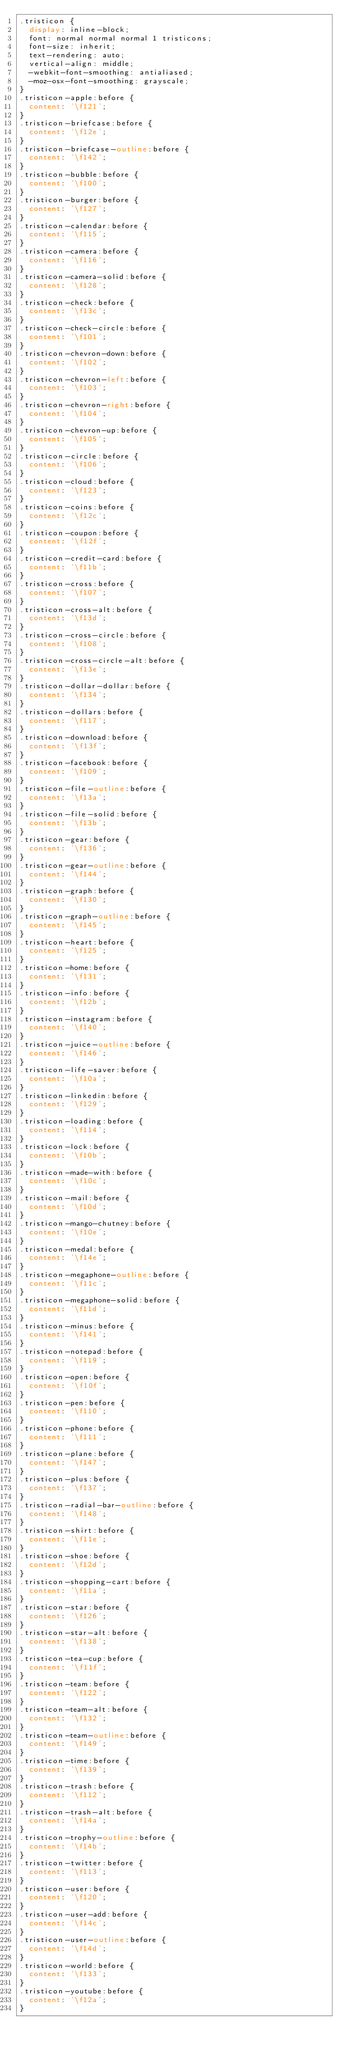Convert code to text. <code><loc_0><loc_0><loc_500><loc_500><_CSS_>.tristicon {
  display: inline-block;
  font: normal normal normal 1 tristicons;
  font-size: inherit;
  text-rendering: auto;
  vertical-align: middle;
  -webkit-font-smoothing: antialiased;
  -moz-osx-font-smoothing: grayscale;
}
.tristicon-apple:before {
  content: '\f121';
}
.tristicon-briefcase:before {
  content: '\f12e';
}
.tristicon-briefcase-outline:before {
  content: '\f142';
}
.tristicon-bubble:before {
  content: '\f100';
}
.tristicon-burger:before {
  content: '\f127';
}
.tristicon-calendar:before {
  content: '\f115';
}
.tristicon-camera:before {
  content: '\f116';
}
.tristicon-camera-solid:before {
  content: '\f128';
}
.tristicon-check:before {
  content: '\f13c';
}
.tristicon-check-circle:before {
  content: '\f101';
}
.tristicon-chevron-down:before {
  content: '\f102';
}
.tristicon-chevron-left:before {
  content: '\f103';
}
.tristicon-chevron-right:before {
  content: '\f104';
}
.tristicon-chevron-up:before {
  content: '\f105';
}
.tristicon-circle:before {
  content: '\f106';
}
.tristicon-cloud:before {
  content: '\f123';
}
.tristicon-coins:before {
  content: '\f12c';
}
.tristicon-coupon:before {
  content: '\f12f';
}
.tristicon-credit-card:before {
  content: '\f11b';
}
.tristicon-cross:before {
  content: '\f107';
}
.tristicon-cross-alt:before {
  content: '\f13d';
}
.tristicon-cross-circle:before {
  content: '\f108';
}
.tristicon-cross-circle-alt:before {
  content: '\f13e';
}
.tristicon-dollar-dollar:before {
  content: '\f134';
}
.tristicon-dollars:before {
  content: '\f117';
}
.tristicon-download:before {
  content: '\f13f';
}
.tristicon-facebook:before {
  content: '\f109';
}
.tristicon-file-outline:before {
  content: '\f13a';
}
.tristicon-file-solid:before {
  content: '\f13b';
}
.tristicon-gear:before {
  content: '\f136';
}
.tristicon-gear-outline:before {
  content: '\f144';
}
.tristicon-graph:before {
  content: '\f130';
}
.tristicon-graph-outline:before {
  content: '\f145';
}
.tristicon-heart:before {
  content: '\f125';
}
.tristicon-home:before {
  content: '\f131';
}
.tristicon-info:before {
  content: '\f12b';
}
.tristicon-instagram:before {
  content: '\f140';
}
.tristicon-juice-outline:before {
  content: '\f146';
}
.tristicon-life-saver:before {
  content: '\f10a';
}
.tristicon-linkedin:before {
  content: '\f129';
}
.tristicon-loading:before {
  content: '\f114';
}
.tristicon-lock:before {
  content: '\f10b';
}
.tristicon-made-with:before {
  content: '\f10c';
}
.tristicon-mail:before {
  content: '\f10d';
}
.tristicon-mango-chutney:before {
  content: '\f10e';
}
.tristicon-medal:before {
  content: '\f14e';
}
.tristicon-megaphone-outline:before {
  content: '\f11c';
}
.tristicon-megaphone-solid:before {
  content: '\f11d';
}
.tristicon-minus:before {
  content: '\f141';
}
.tristicon-notepad:before {
  content: '\f119';
}
.tristicon-open:before {
  content: '\f10f';
}
.tristicon-pen:before {
  content: '\f110';
}
.tristicon-phone:before {
  content: '\f111';
}
.tristicon-plane:before {
  content: '\f147';
}
.tristicon-plus:before {
  content: '\f137';
}
.tristicon-radial-bar-outline:before {
  content: '\f148';
}
.tristicon-shirt:before {
  content: '\f11e';
}
.tristicon-shoe:before {
  content: '\f12d';
}
.tristicon-shopping-cart:before {
  content: '\f11a';
}
.tristicon-star:before {
  content: '\f126';
}
.tristicon-star-alt:before {
  content: '\f138';
}
.tristicon-tea-cup:before {
  content: '\f11f';
}
.tristicon-team:before {
  content: '\f122';
}
.tristicon-team-alt:before {
  content: '\f132';
}
.tristicon-team-outline:before {
  content: '\f149';
}
.tristicon-time:before {
  content: '\f139';
}
.tristicon-trash:before {
  content: '\f112';
}
.tristicon-trash-alt:before {
  content: '\f14a';
}
.tristicon-trophy-outline:before {
  content: '\f14b';
}
.tristicon-twitter:before {
  content: '\f113';
}
.tristicon-user:before {
  content: '\f120';
}
.tristicon-user-add:before {
  content: '\f14c';
}
.tristicon-user-outline:before {
  content: '\f14d';
}
.tristicon-world:before {
  content: '\f133';
}
.tristicon-youtube:before {
  content: '\f12a';
}
</code> 